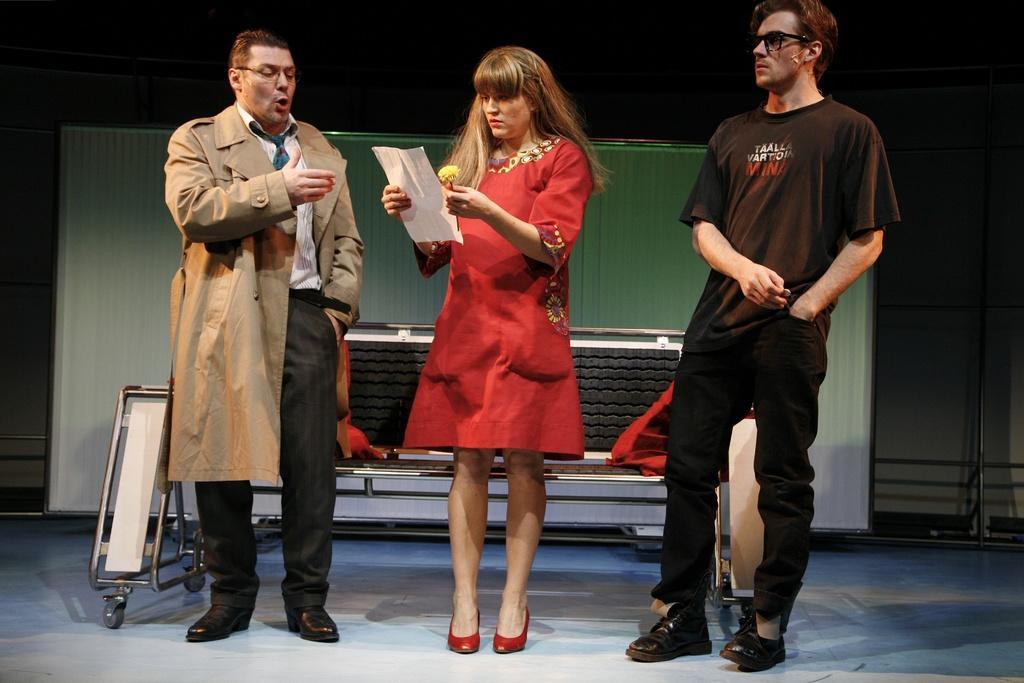Please provide a concise description of this image. In this picture, we can see there are three people standing on the stage and a woman in the red dress is holding a paper and a flower. Behind the people there is a bench and other things. 